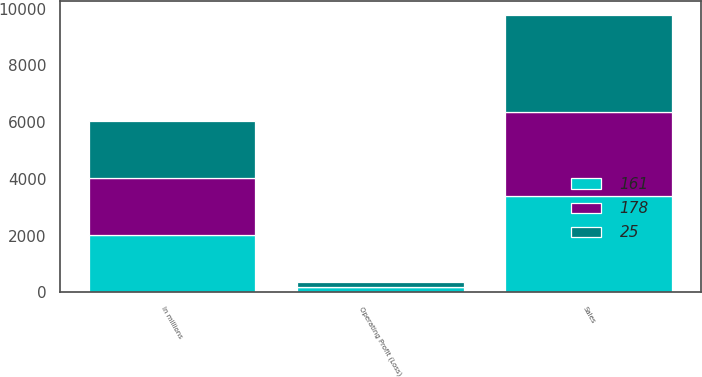Convert chart. <chart><loc_0><loc_0><loc_500><loc_500><stacked_bar_chart><ecel><fcel>In millions<fcel>Sales<fcel>Operating Profit (Loss)<nl><fcel>178<fcel>2015<fcel>2940<fcel>25<nl><fcel>161<fcel>2014<fcel>3403<fcel>178<nl><fcel>25<fcel>2013<fcel>3435<fcel>161<nl></chart> 